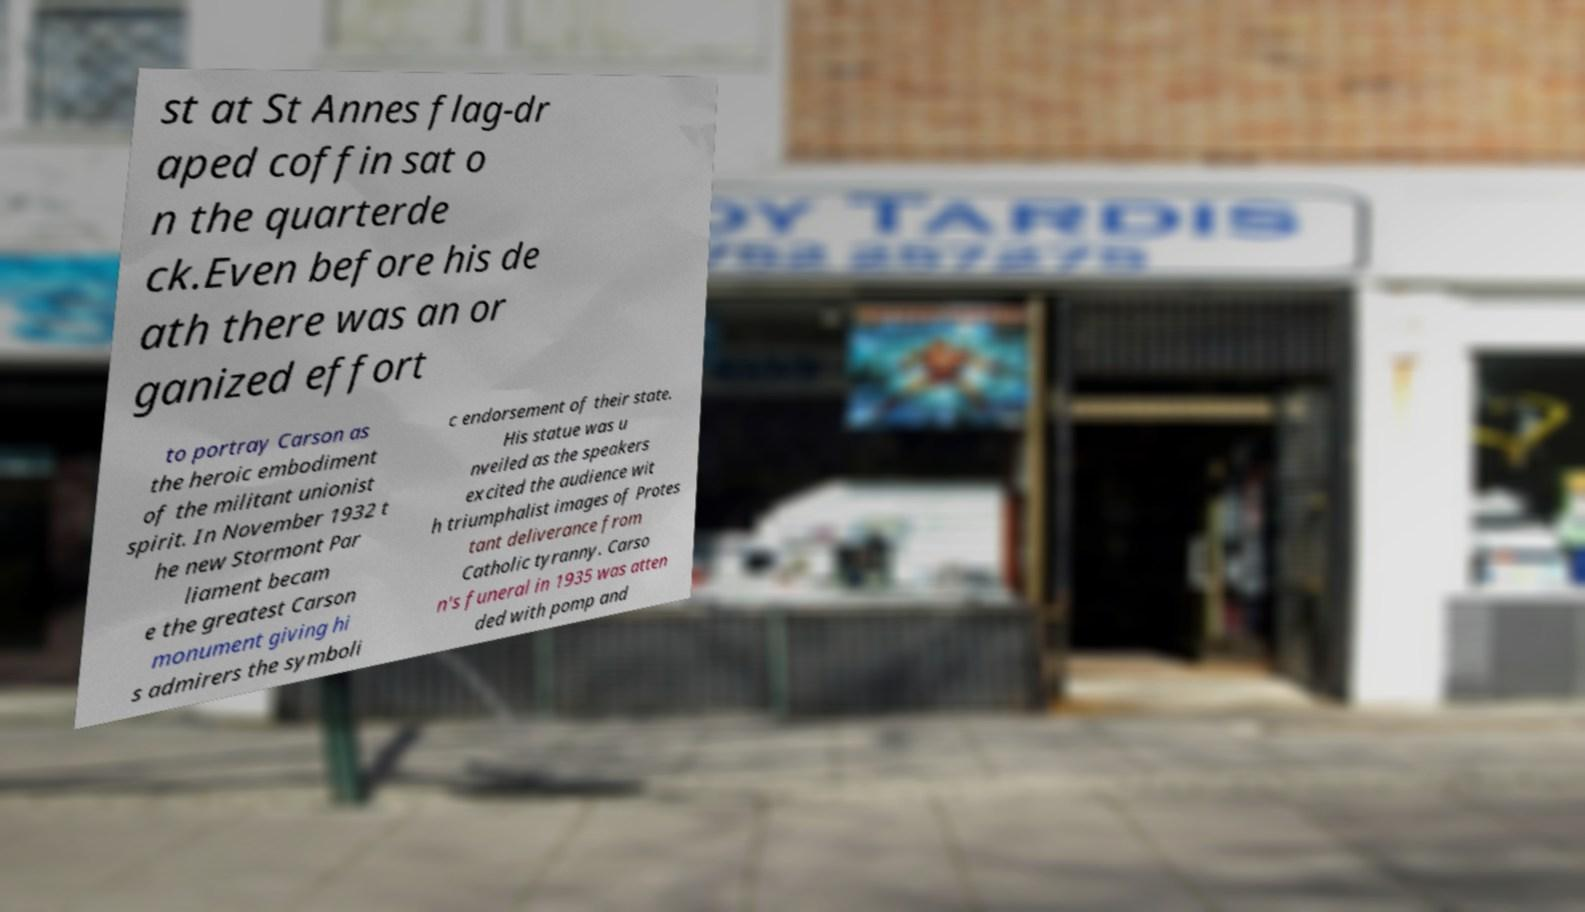Can you accurately transcribe the text from the provided image for me? st at St Annes flag-dr aped coffin sat o n the quarterde ck.Even before his de ath there was an or ganized effort to portray Carson as the heroic embodiment of the militant unionist spirit. In November 1932 t he new Stormont Par liament becam e the greatest Carson monument giving hi s admirers the symboli c endorsement of their state. His statue was u nveiled as the speakers excited the audience wit h triumphalist images of Protes tant deliverance from Catholic tyranny. Carso n's funeral in 1935 was atten ded with pomp and 